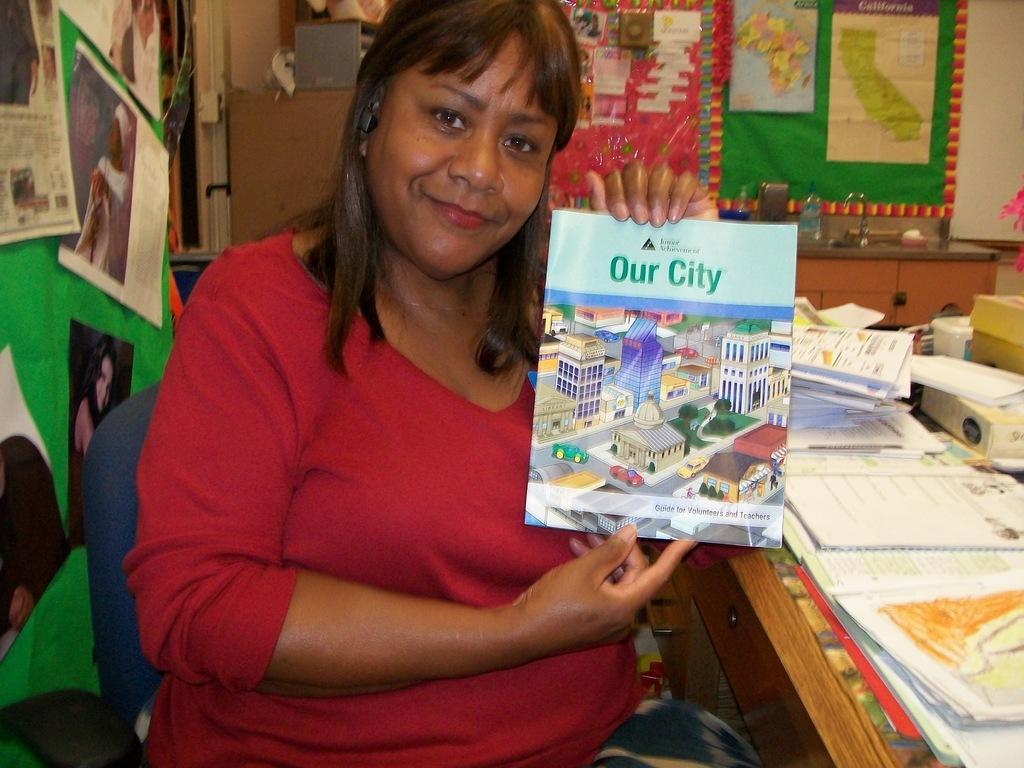Describe this image in one or two sentences. In this image we can see a woman holding a book sitting beside a table containing a group of books. On the backside we can see some charts pasted on a wall. We can also see a sink and a bottle on a table. 